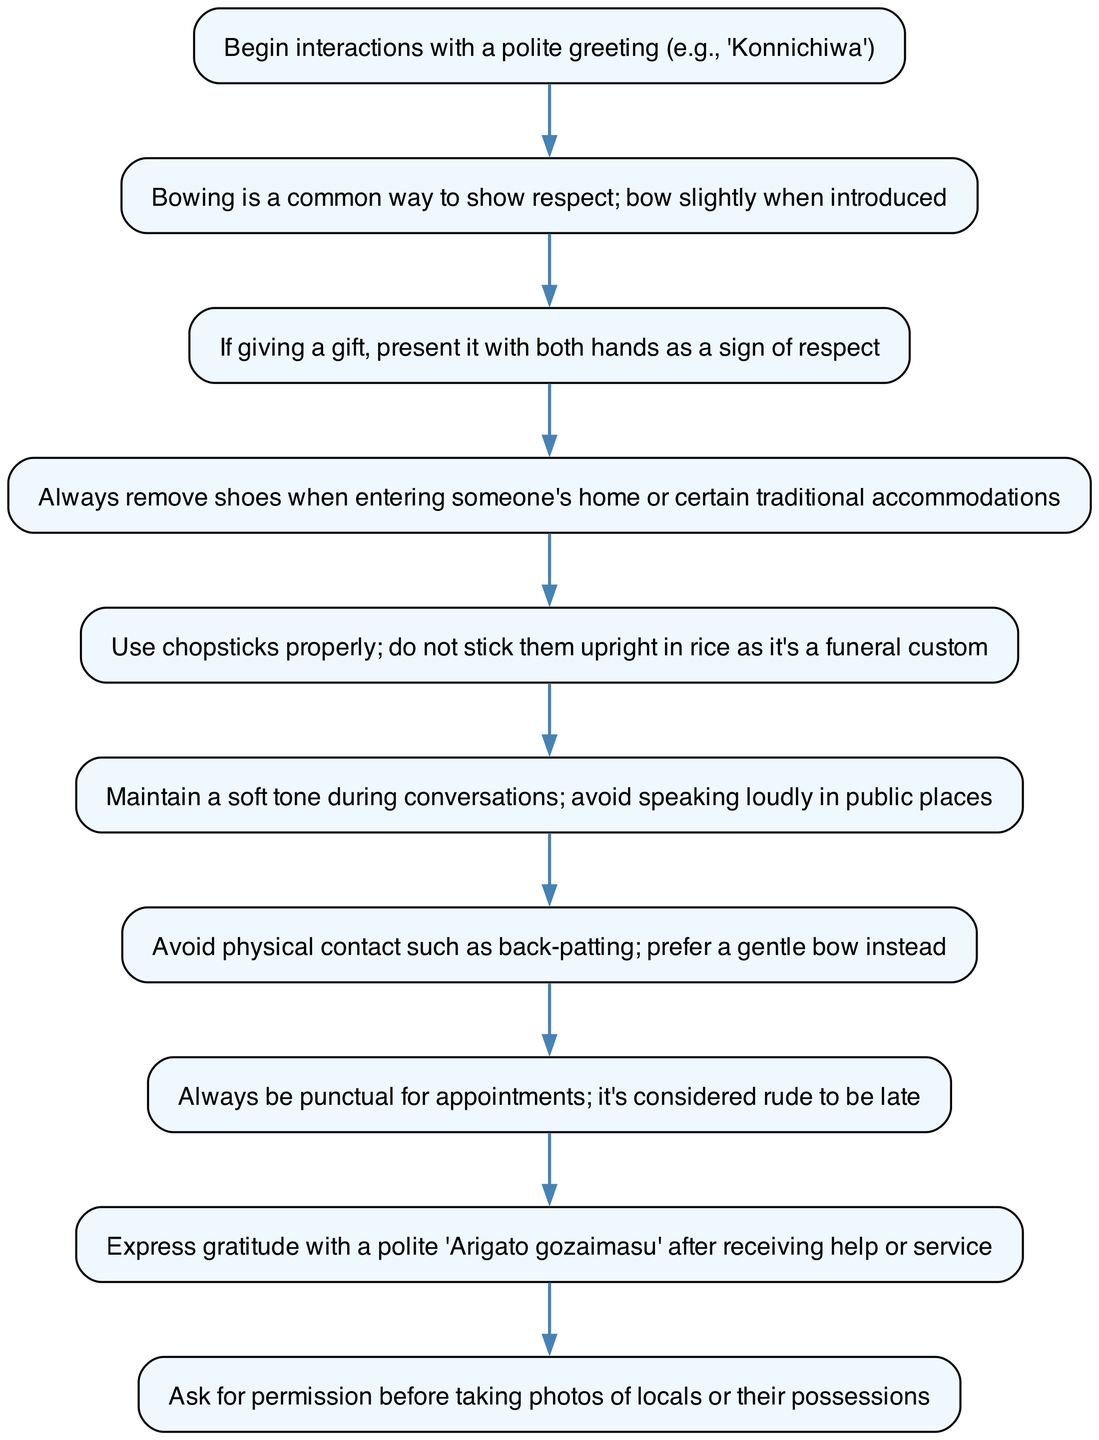What is the first step in the flow? The first step in the flow is indicated as the initial node before any other node, which is "Begin interactions with a polite greeting (e.g., 'Konnichiwa')".
Answer: Begin interactions with a polite greeting (e.g., 'Konnichiwa') How many steps are shown in the flow chart? The number of steps can be counted from the diagram by counting the nodes, which total ten steps in this case.
Answer: 10 What should you do after receiving help or service? The appropriate action is expressed explicitly in the last step of the flow, which states you should express gratitude with a polite "Arigato gozaimasu".
Answer: Express gratitude with a polite 'Arigato gozaimasu' Is there a step about punctuality? Yes, there is a step that explicitly mentions punctuality which states, "Always be punctual for appointments; it's considered rude to be late".
Answer: Always be punctual for appointments; it's considered rude to be late What is advised against when interacting publicly? In the flow, there is a specific guideline regarding public behavior that advises against physical contact, stating to "Avoid physical contact such as back-patting; prefer a gentle bow instead."
Answer: Avoid physical contact such as back-patting; prefer a gentle bow instead What is the flow's last step? The last step of the flow can be determined by identifying the final node, which discusses asking for permission before taking pictures of locals or their possessions.
Answer: Ask for permission before taking photos of locals or their possessions Which action is recommended with both hands? The flow includes a guideline that emphasizes a specific action regarding gift-giving, indicating that one should present gifts with both hands as a sign of respect.
Answer: Present it with both hands as a sign of respect What should you avoid doing with chopsticks? The guideline regarding chopsticks explicitly mentions a specific action to avoid, stating "do not stick them upright in rice as it's a funeral custom".
Answer: Do not stick them upright in rice as it's a funeral custom What is the suggested tone of voice during conversations? The diagram highlights maintaining a soft tone during conversations as a polite action, specifically advising to "avoid speaking loudly in public places".
Answer: Maintain a soft tone during conversations; avoid speaking loudly in public places 